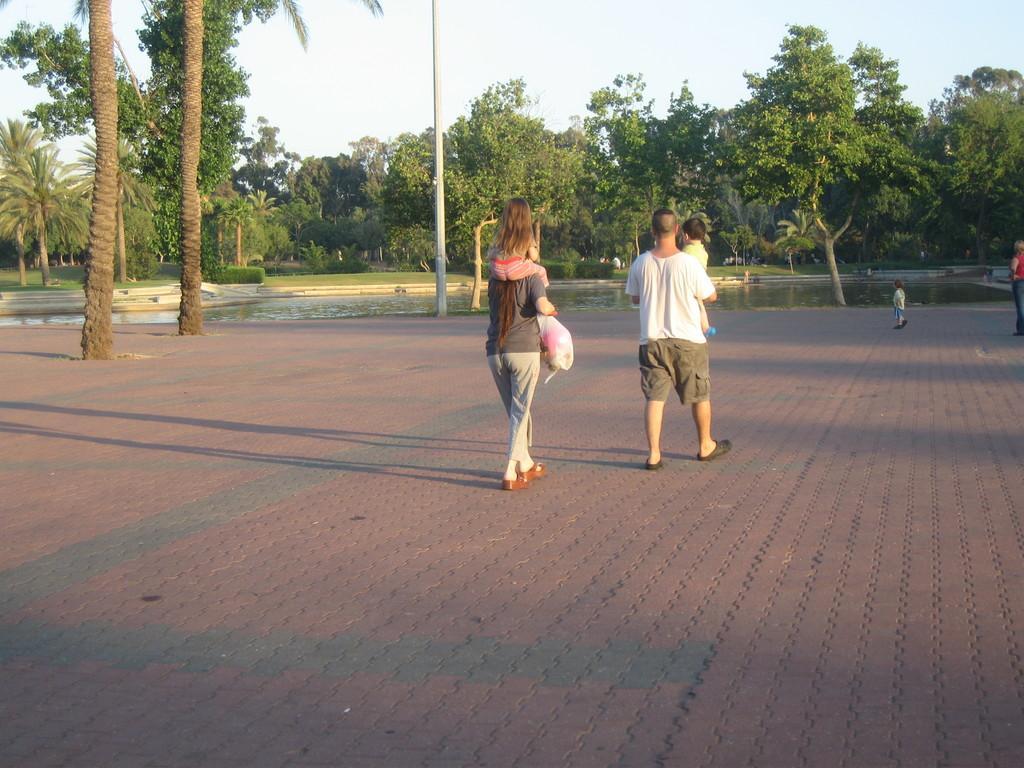Could you give a brief overview of what you see in this image? In the image we can see there are people walking, wearing clothes and shoes. This is a footpath, water, trees, pole, grass, plant and a white sky. 